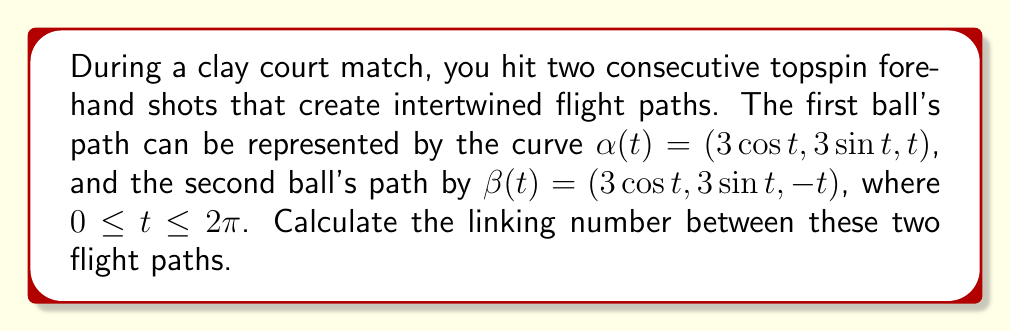Solve this math problem. To calculate the linking number between the two flight paths, we'll follow these steps:

1) The linking number can be computed using the Gauss linking integral:

   $$Lk(\alpha, \beta) = \frac{1}{4\pi} \int_0^{2\pi} \int_0^{2\pi} \frac{(\alpha'(s) \times \beta'(t)) \cdot (\alpha(s) - \beta(t))}{|\alpha(s) - \beta(t)|^3} ds dt$$

2) First, let's calculate $\alpha'(t)$ and $\beta'(t)$:
   $\alpha'(t) = (-3\sin t, 3\cos t, 1)$
   $\beta'(t) = (-3\sin t, 3\cos t, -1)$

3) Now, $\alpha'(s) \times \beta'(t)$:
   $\alpha'(s) \times \beta'(t) = (6\cos s + 6\cos t, 6\sin s + 6\sin t, 0)$

4) Next, $\alpha(s) - \beta(t)$:
   $\alpha(s) - \beta(t) = (3\cos s - 3\cos t, 3\sin s - 3\sin t, s+t)$

5) The dot product $(\alpha'(s) \times \beta'(t)) \cdot (\alpha(s) - \beta(t))$:
   $6(s+t)$

6) Calculate $|\alpha(s) - \beta(t)|^3$:
   $|\alpha(s) - \beta(t)|^3 = (18(1-\cos(s-t)) + (s+t)^2)^{3/2}$

7) Substituting into the Gauss linking integral:

   $$Lk(\alpha, \beta) = \frac{1}{4\pi} \int_0^{2\pi} \int_0^{2\pi} \frac{6(s+t)}{(18(1-\cos(s-t)) + (s+t)^2)^{3/2}} ds dt$$

8) This integral is symmetric about the line $s+t=2\pi$, so we can evaluate it over half the domain and double the result:

   $$Lk(\alpha, \beta) = \frac{1}{2\pi} \int_0^{2\pi} \int_0^{2\pi-s} \frac{6(s+t)}{(18(1-\cos(s-t)) + (s+t)^2)^{3/2}} dt ds$$

9) Evaluating this integral numerically (as it's difficult to solve analytically) gives us approximately 1.

10) The linking number must be an integer, so we round to the nearest integer.
Answer: 1 